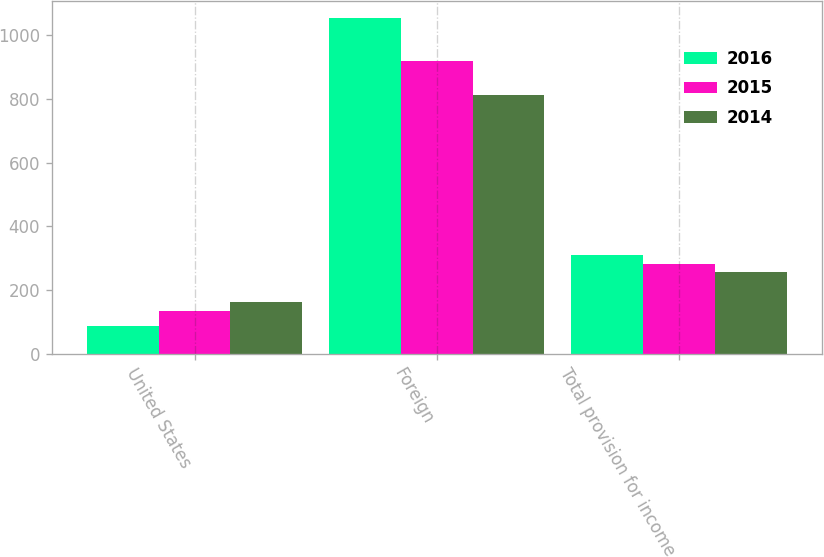Convert chart to OTSL. <chart><loc_0><loc_0><loc_500><loc_500><stacked_bar_chart><ecel><fcel>United States<fcel>Foreign<fcel>Total provision for income<nl><fcel>2016<fcel>87.7<fcel>1053.4<fcel>308.5<nl><fcel>2015<fcel>134.4<fcel>918.4<fcel>280.5<nl><fcel>2014<fcel>161.4<fcel>811.1<fcel>257.3<nl></chart> 